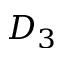Convert formula to latex. <formula><loc_0><loc_0><loc_500><loc_500>D _ { 3 }</formula> 